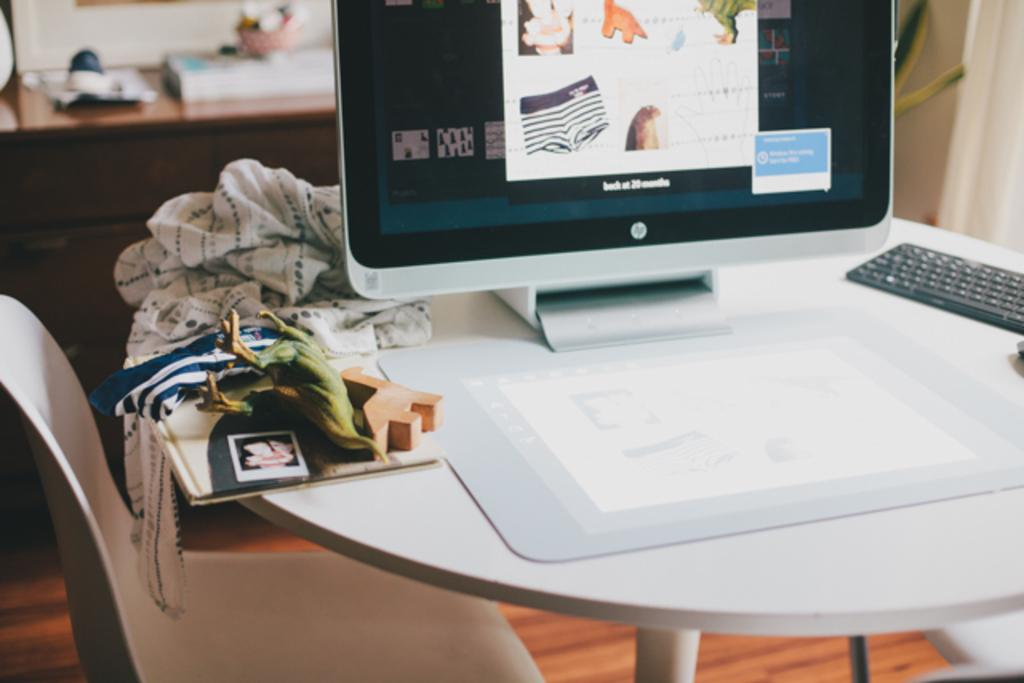What type of furniture is present in the image? There is a table and a chair in the image. What electronic devices are on the table? There is a monitor and a keyboard on the table. How does the wealth of the person using the computer in the image affect the image? The wealth of the person using the computer is not visible or mentioned in the image, so it cannot affect the image. 